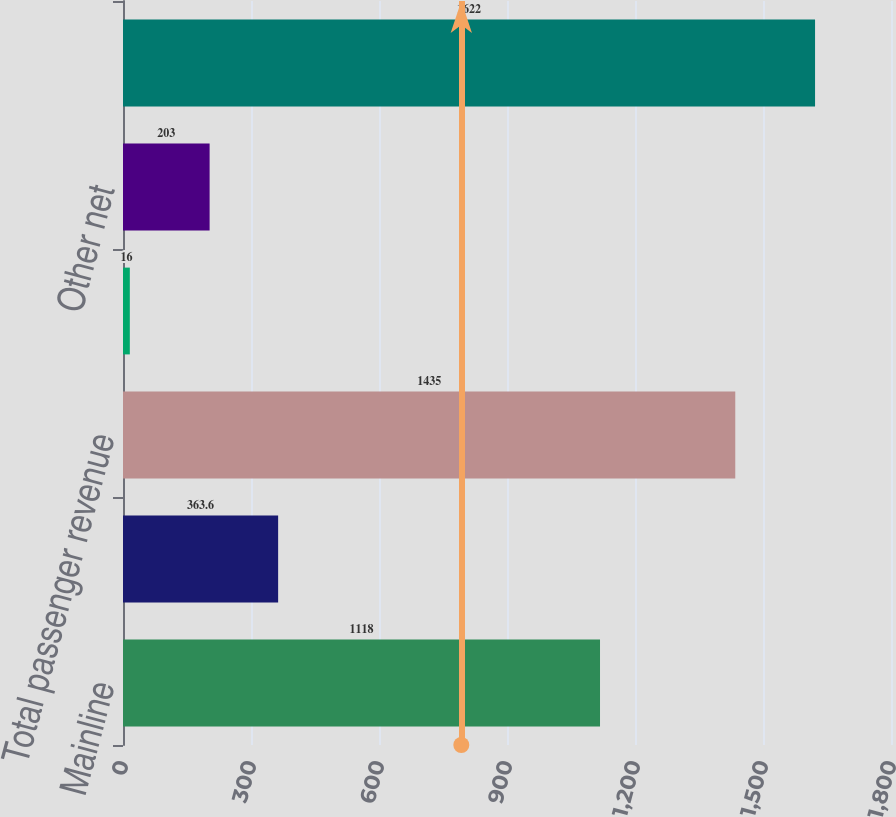<chart> <loc_0><loc_0><loc_500><loc_500><bar_chart><fcel>Mainline<fcel>Regional affiliates<fcel>Total passenger revenue<fcel>Cargo<fcel>Other net<fcel>Total operating revenue<nl><fcel>1118<fcel>363.6<fcel>1435<fcel>16<fcel>203<fcel>1622<nl></chart> 